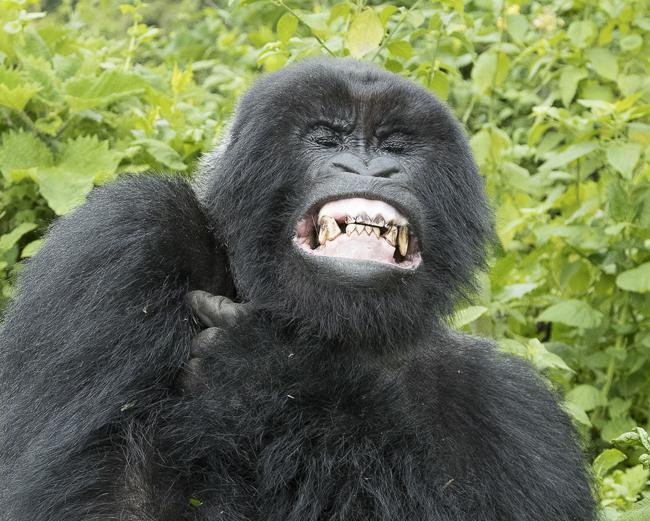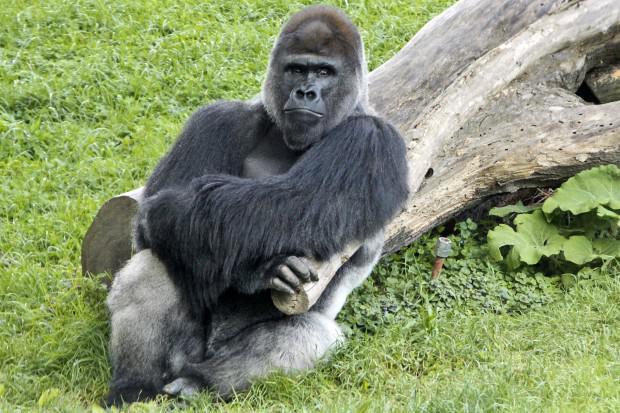The first image is the image on the left, the second image is the image on the right. For the images displayed, is the sentence "A gorilla is eating a plant in one of the images." factually correct? Answer yes or no. No. 